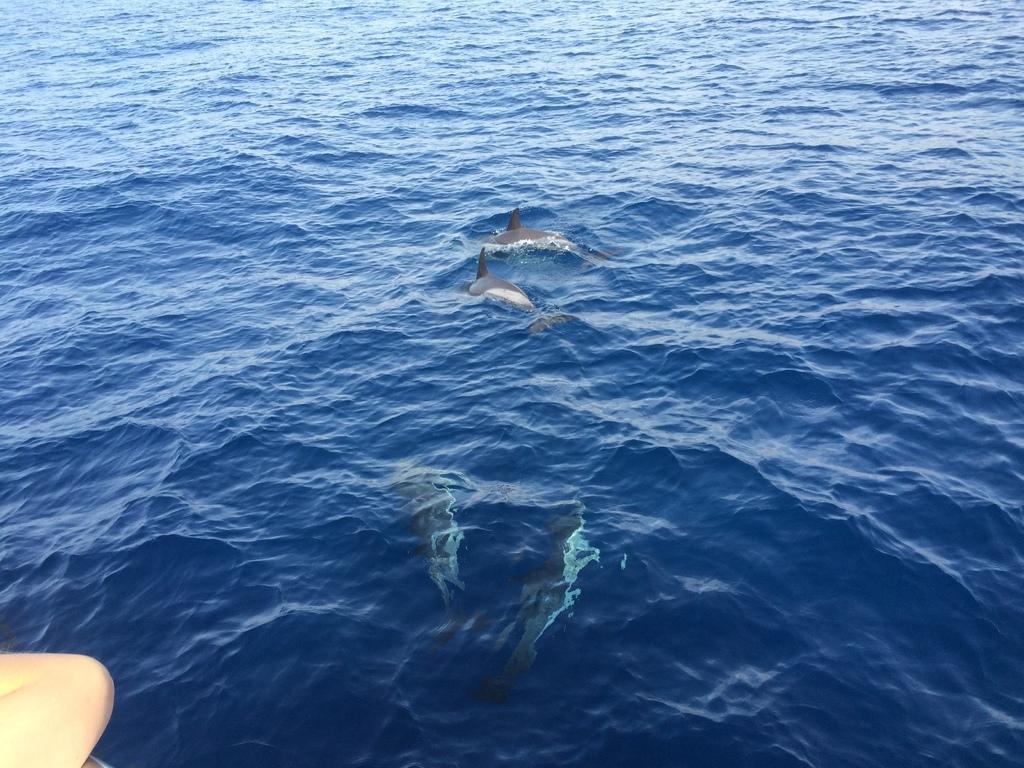How would you summarize this image in a sentence or two? In this image we can see there are dolphins in the river. At the bottom left side of the image there is a hand of a person. 